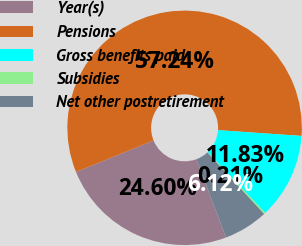<chart> <loc_0><loc_0><loc_500><loc_500><pie_chart><fcel>Year(s)<fcel>Pensions<fcel>Gross benefits paid<fcel>Subsidies<fcel>Net other postretirement<nl><fcel>24.6%<fcel>57.24%<fcel>11.83%<fcel>0.21%<fcel>6.12%<nl></chart> 